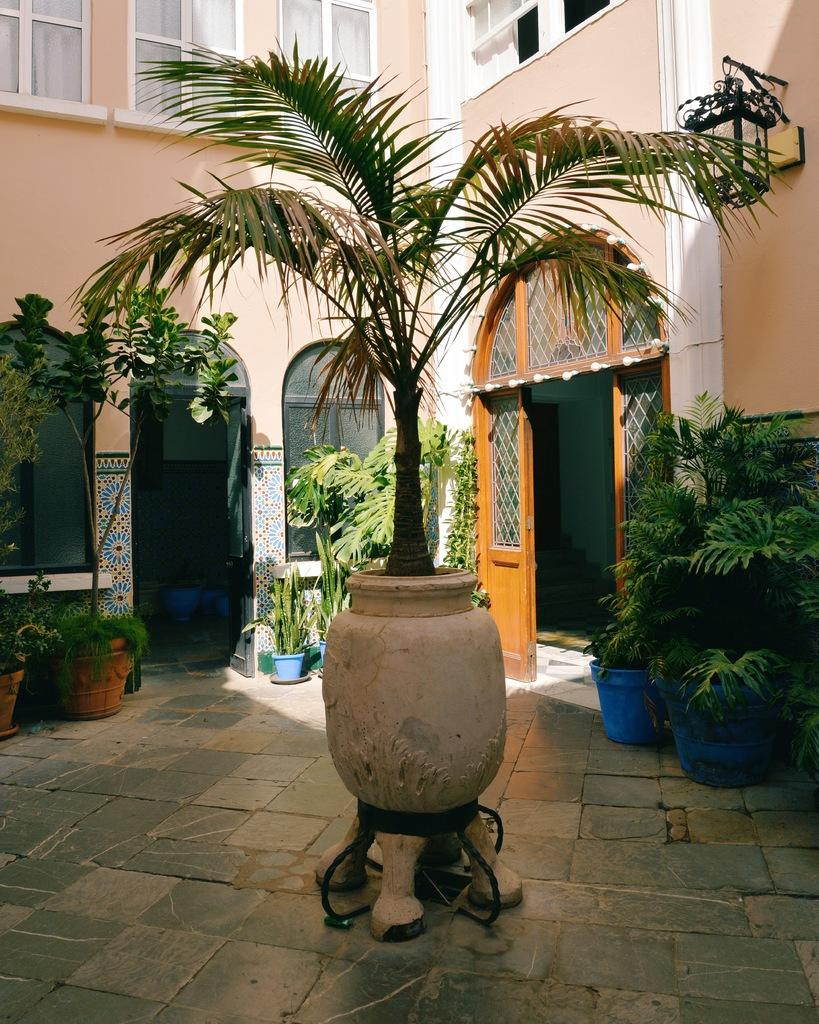What is the main structure in the picture? There is a building in the picture. What is located in front of the building? There are plants in front of the building. Where is the door on the building? The door is on the right side of the building. What can be seen at the center of the plants? A tree is present at the center of the plants. Reasoning: Let's think step by step by step in order to produce the conversation. We start by identifying the main structure in the image, which is the building. Then, we describe the surrounding environment, including the plants and the tree. Finally, we focus on a specific detail of the building, which is the door on the right side. Each question is designed to elicit a specific detail about the image that is known from the provided facts. Absurd Question/Answer: What type of fruit is hanging from the tree in the image? There is no fruit visible on the tree in the image. What print can be seen on the building's facade? The image does not provide information about any prints or patterns on the building's facade. What type of fruit is hanging from the tree in the image? There is no fruit visible on the tree in the image. What print can be seen on the building's facade? The image does not provide information about any prints or patterns on the building's facade. 